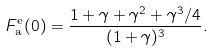Convert formula to latex. <formula><loc_0><loc_0><loc_500><loc_500>F _ { \text {a} } ^ { \text {e} } ( 0 ) = \frac { 1 + \gamma + \gamma ^ { 2 } + \gamma ^ { 3 } / 4 } { ( 1 + \gamma ) ^ { 3 } } .</formula> 